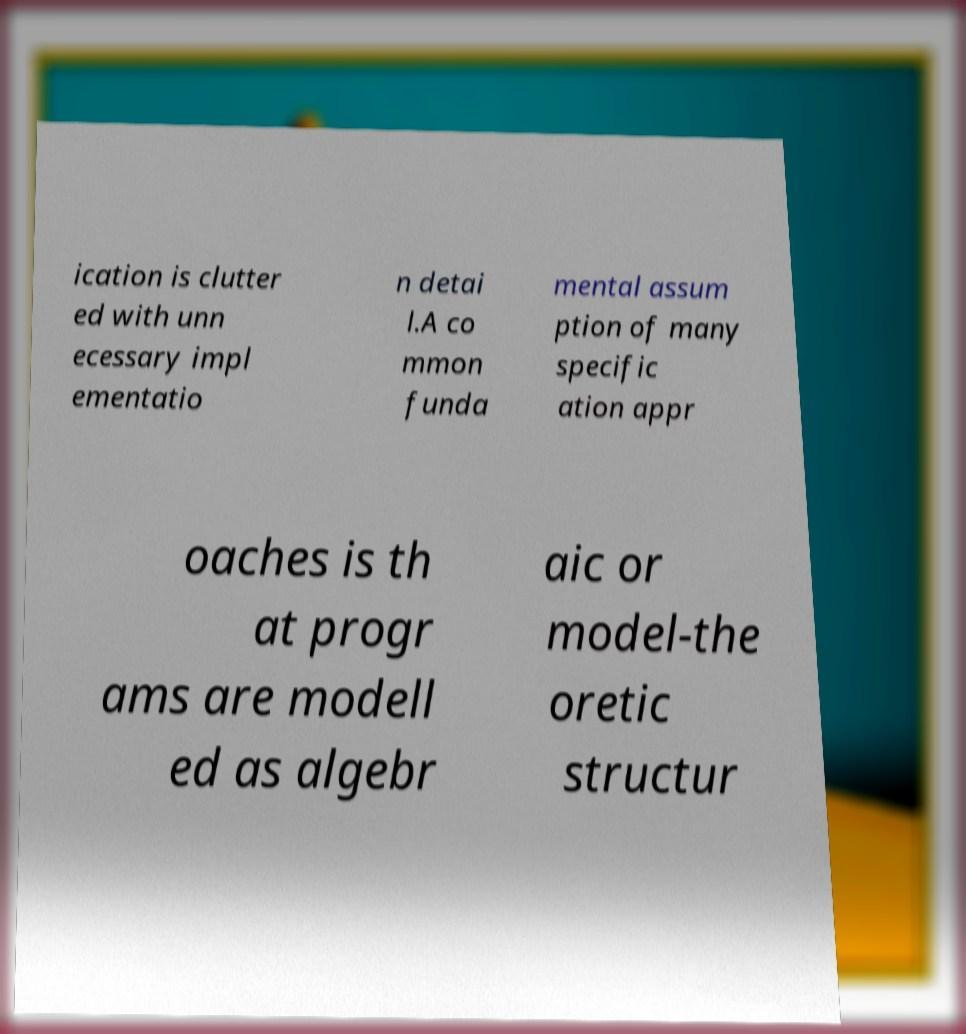What messages or text are displayed in this image? I need them in a readable, typed format. ication is clutter ed with unn ecessary impl ementatio n detai l.A co mmon funda mental assum ption of many specific ation appr oaches is th at progr ams are modell ed as algebr aic or model-the oretic structur 